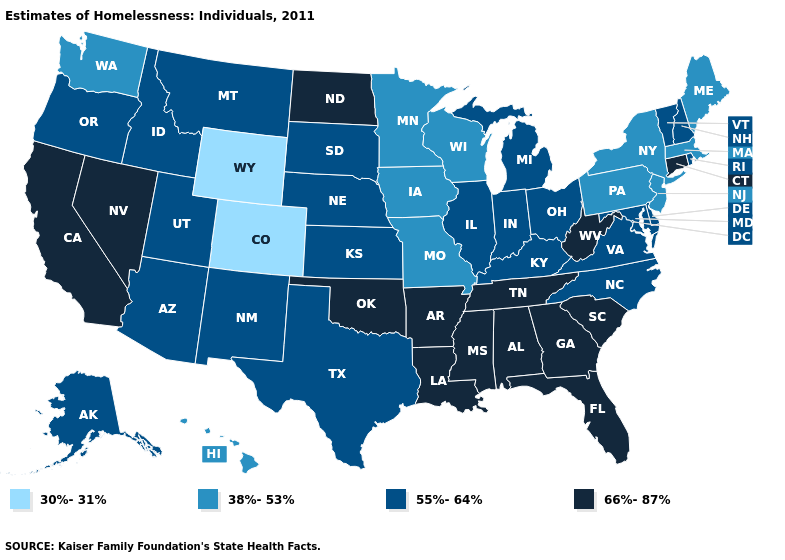Name the states that have a value in the range 55%-64%?
Keep it brief. Alaska, Arizona, Delaware, Idaho, Illinois, Indiana, Kansas, Kentucky, Maryland, Michigan, Montana, Nebraska, New Hampshire, New Mexico, North Carolina, Ohio, Oregon, Rhode Island, South Dakota, Texas, Utah, Vermont, Virginia. What is the highest value in states that border Tennessee?
Write a very short answer. 66%-87%. Does Michigan have the same value as Arizona?
Write a very short answer. Yes. What is the value of Maine?
Short answer required. 38%-53%. Name the states that have a value in the range 66%-87%?
Give a very brief answer. Alabama, Arkansas, California, Connecticut, Florida, Georgia, Louisiana, Mississippi, Nevada, North Dakota, Oklahoma, South Carolina, Tennessee, West Virginia. What is the value of Kentucky?
Answer briefly. 55%-64%. Does North Dakota have the highest value in the MidWest?
Concise answer only. Yes. Name the states that have a value in the range 38%-53%?
Be succinct. Hawaii, Iowa, Maine, Massachusetts, Minnesota, Missouri, New Jersey, New York, Pennsylvania, Washington, Wisconsin. What is the highest value in states that border Mississippi?
Concise answer only. 66%-87%. What is the value of Utah?
Be succinct. 55%-64%. Name the states that have a value in the range 30%-31%?
Short answer required. Colorado, Wyoming. Name the states that have a value in the range 38%-53%?
Short answer required. Hawaii, Iowa, Maine, Massachusetts, Minnesota, Missouri, New Jersey, New York, Pennsylvania, Washington, Wisconsin. What is the value of Alaska?
Answer briefly. 55%-64%. Name the states that have a value in the range 66%-87%?
Write a very short answer. Alabama, Arkansas, California, Connecticut, Florida, Georgia, Louisiana, Mississippi, Nevada, North Dakota, Oklahoma, South Carolina, Tennessee, West Virginia. What is the lowest value in the Northeast?
Be succinct. 38%-53%. 